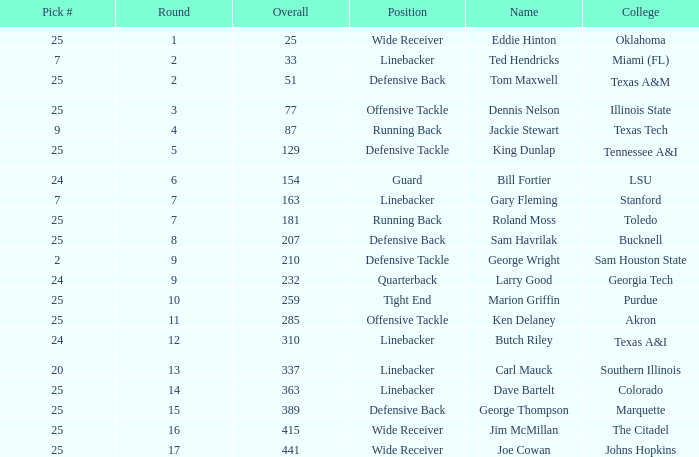Round smaller than 7, and an Overall of 129 is what college? Tennessee A&I. 